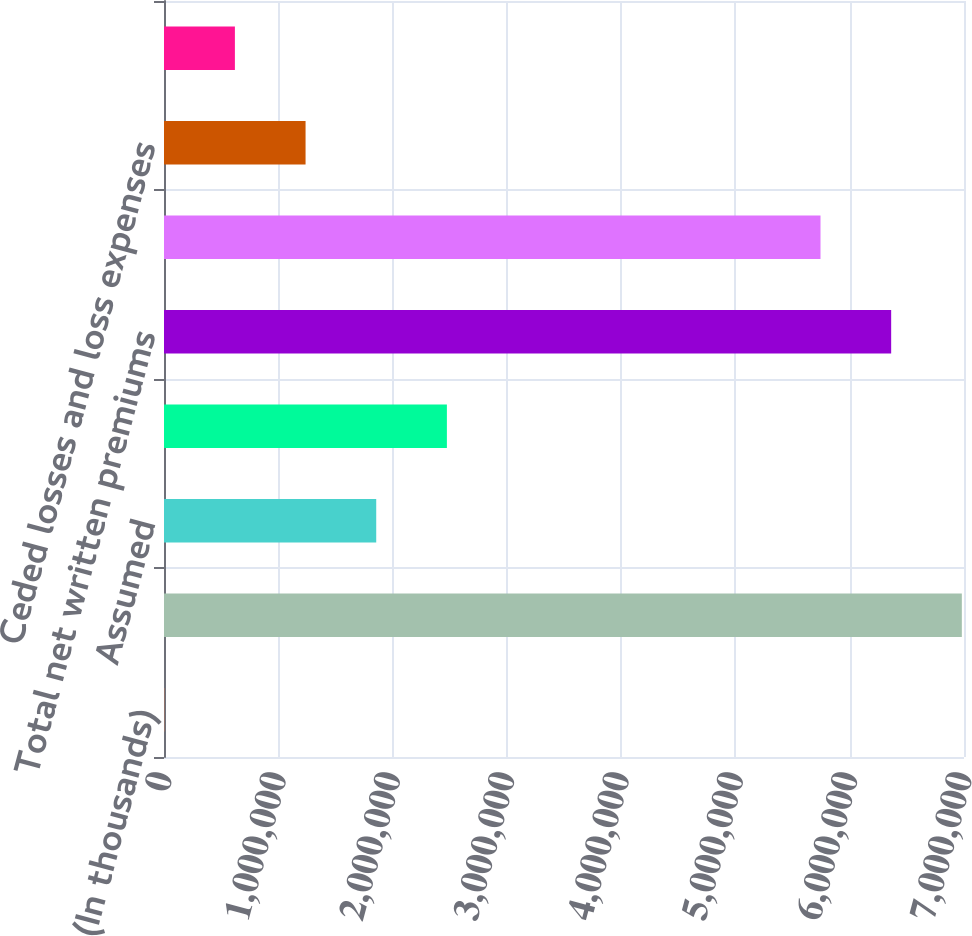<chart> <loc_0><loc_0><loc_500><loc_500><bar_chart><fcel>(In thousands)<fcel>Direct<fcel>Assumed<fcel>Ceded<fcel>Total net written premiums<fcel>Total net earned premiums<fcel>Ceded losses and loss expenses<fcel>Ceded commission earned<nl><fcel>2014<fcel>6.98106e+06<fcel>1.85698e+06<fcel>2.47531e+06<fcel>6.36274e+06<fcel>5.74442e+06<fcel>1.23866e+06<fcel>620337<nl></chart> 